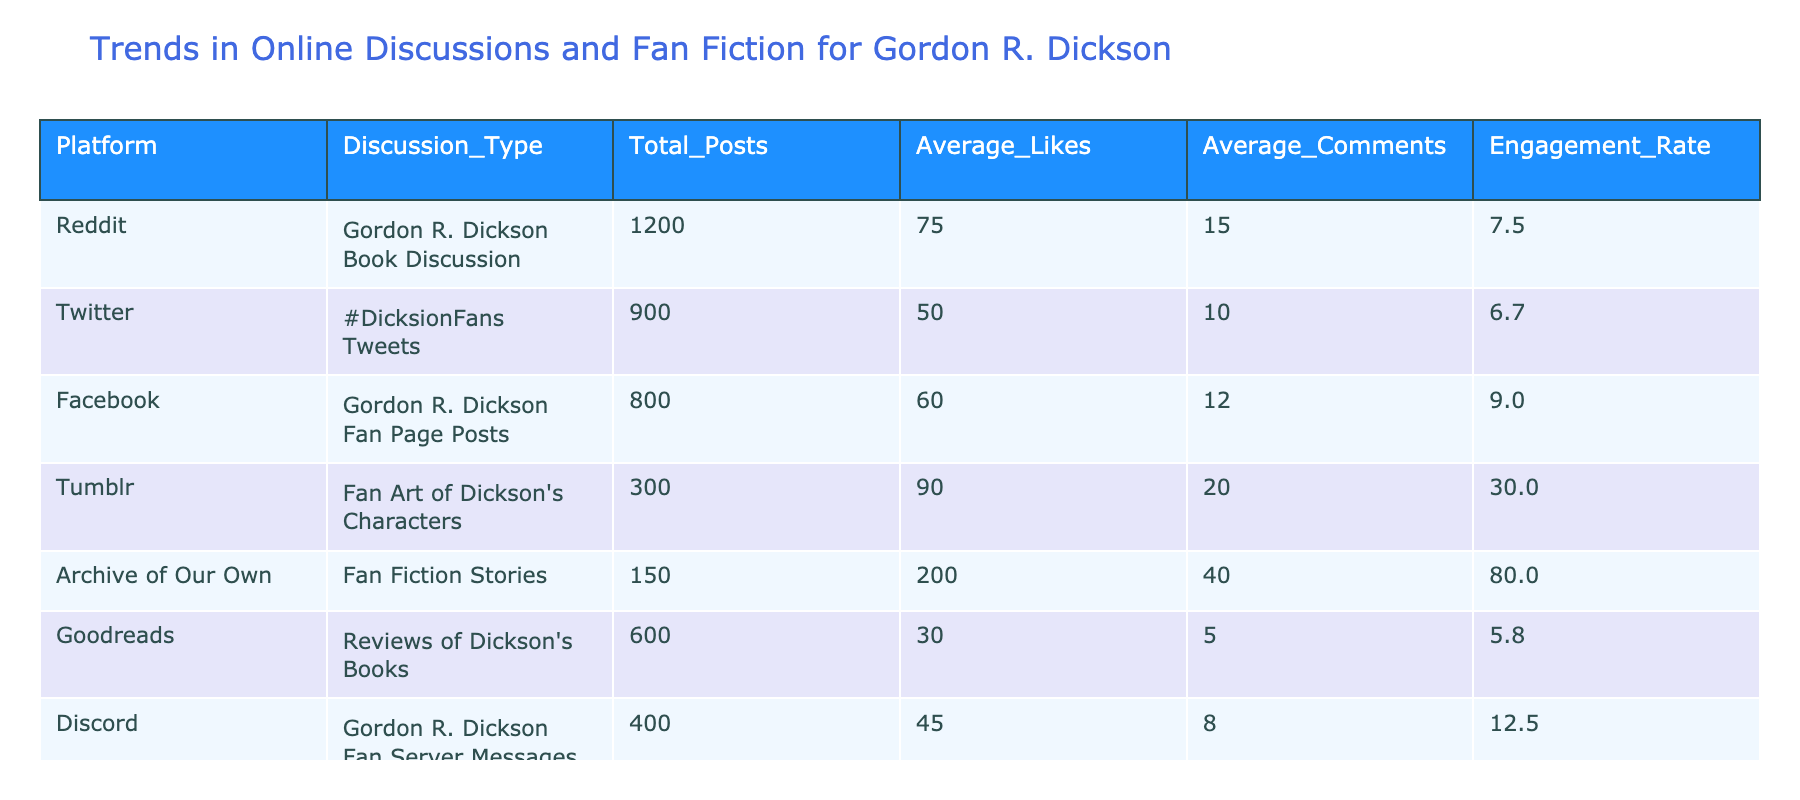What is the total number of posts about Gordon R. Dickson on Twitter? From the table, the 'Total_Posts' column for Twitter shows a value of 900. Therefore, the total number of posts about Gordon R. Dickson on Twitter is directly retrieved from that column.
Answer: 900 Which platform has the highest average likes for discussions related to Dickson's works? Looking at the 'Average_Likes' column, Archive of Our Own has the highest value listed at 200. This makes it the platform with the highest average likes for discussions about Dickson's works.
Answer: Archive of Our Own What is the engagement rate difference between Facebook and Goodreads? The engagement rate for Facebook is 9.0, while for Goodreads, it is 5.8. To find the difference, subtract the engagement rate of Goodreads from that of Facebook: 9.0 - 5.8 = 3.2.
Answer: 3.2 Does Discord have more average comments than the Twitter posts about Dickson? From the table, Discord has an average of 8 comments, and Twitter has an average of 10 comments. Since 8 is less than 10, the statement is false.
Answer: No What is the combined total of posts on Reddit and Tumblr? For Reddit, the total number of posts is 1200, and for Tumblr, it is 300. The combined total is calculated by summing these values: 1200 + 300 = 1500.
Answer: 1500 Is the total number of posts on Archive of Our Own greater than the total of posts across Facebook and Instagram combined? Archive of Our Own has 150 posts, while Facebook has 800 and Instagram has 200. The combined total for Facebook and Instagram is 800 + 200 = 1000, which is greater than the posts on Archive of Our Own. Therefore, the statement is false.
Answer: No What is the platform with the lowest average comments, and what is that number? By examining the 'Average_Comments' column, Goodreads has the lowest average comments at 5. This makes Goodreads the platform with the least interaction in terms of comments on Dickson's works.
Answer: Goodreads, 5 How many platforms have an engagement rate higher than 15? Reviewing the 'Engagement_Rate' column, only Archive of Our Own (80.0) and Tumblr (30.0) have rates higher than 15. Thus, there are 2 platforms that exceed this threshold.
Answer: 2 What is the average likes for the posts on platforms where the total posts exceed 500? The platforms with total posts exceeding 500 are Reddit (75 likes), Twitter (50 likes), Facebook (60 likes), and Goodreads (30 likes). The average is calculated as (75 + 50 + 60 + 30) / 4 = 53.75.
Answer: 53.75 Which type of discussion has the least number of total posts? By checking the 'Total_Posts' column, it is clear that the type of discussion with the least posts is Tumblr with 300 posts.
Answer: Tumblr 